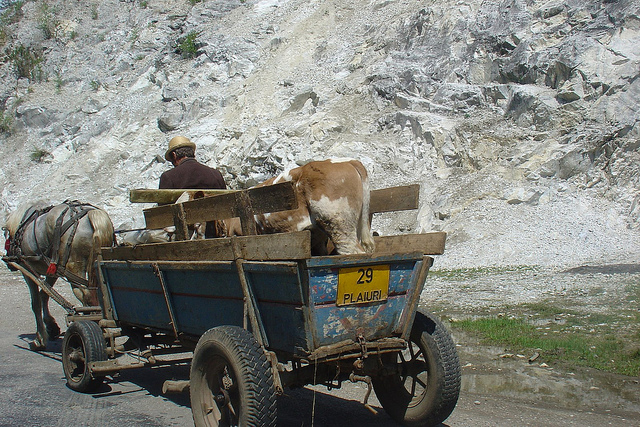Identify the text displayed in this image. 29 PLAIURI 